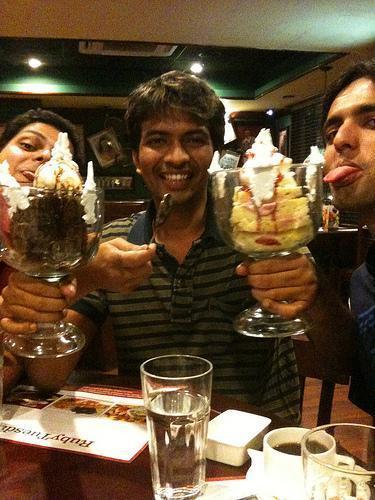How many desserts is the man holding?
Give a very brief answer. 2. 